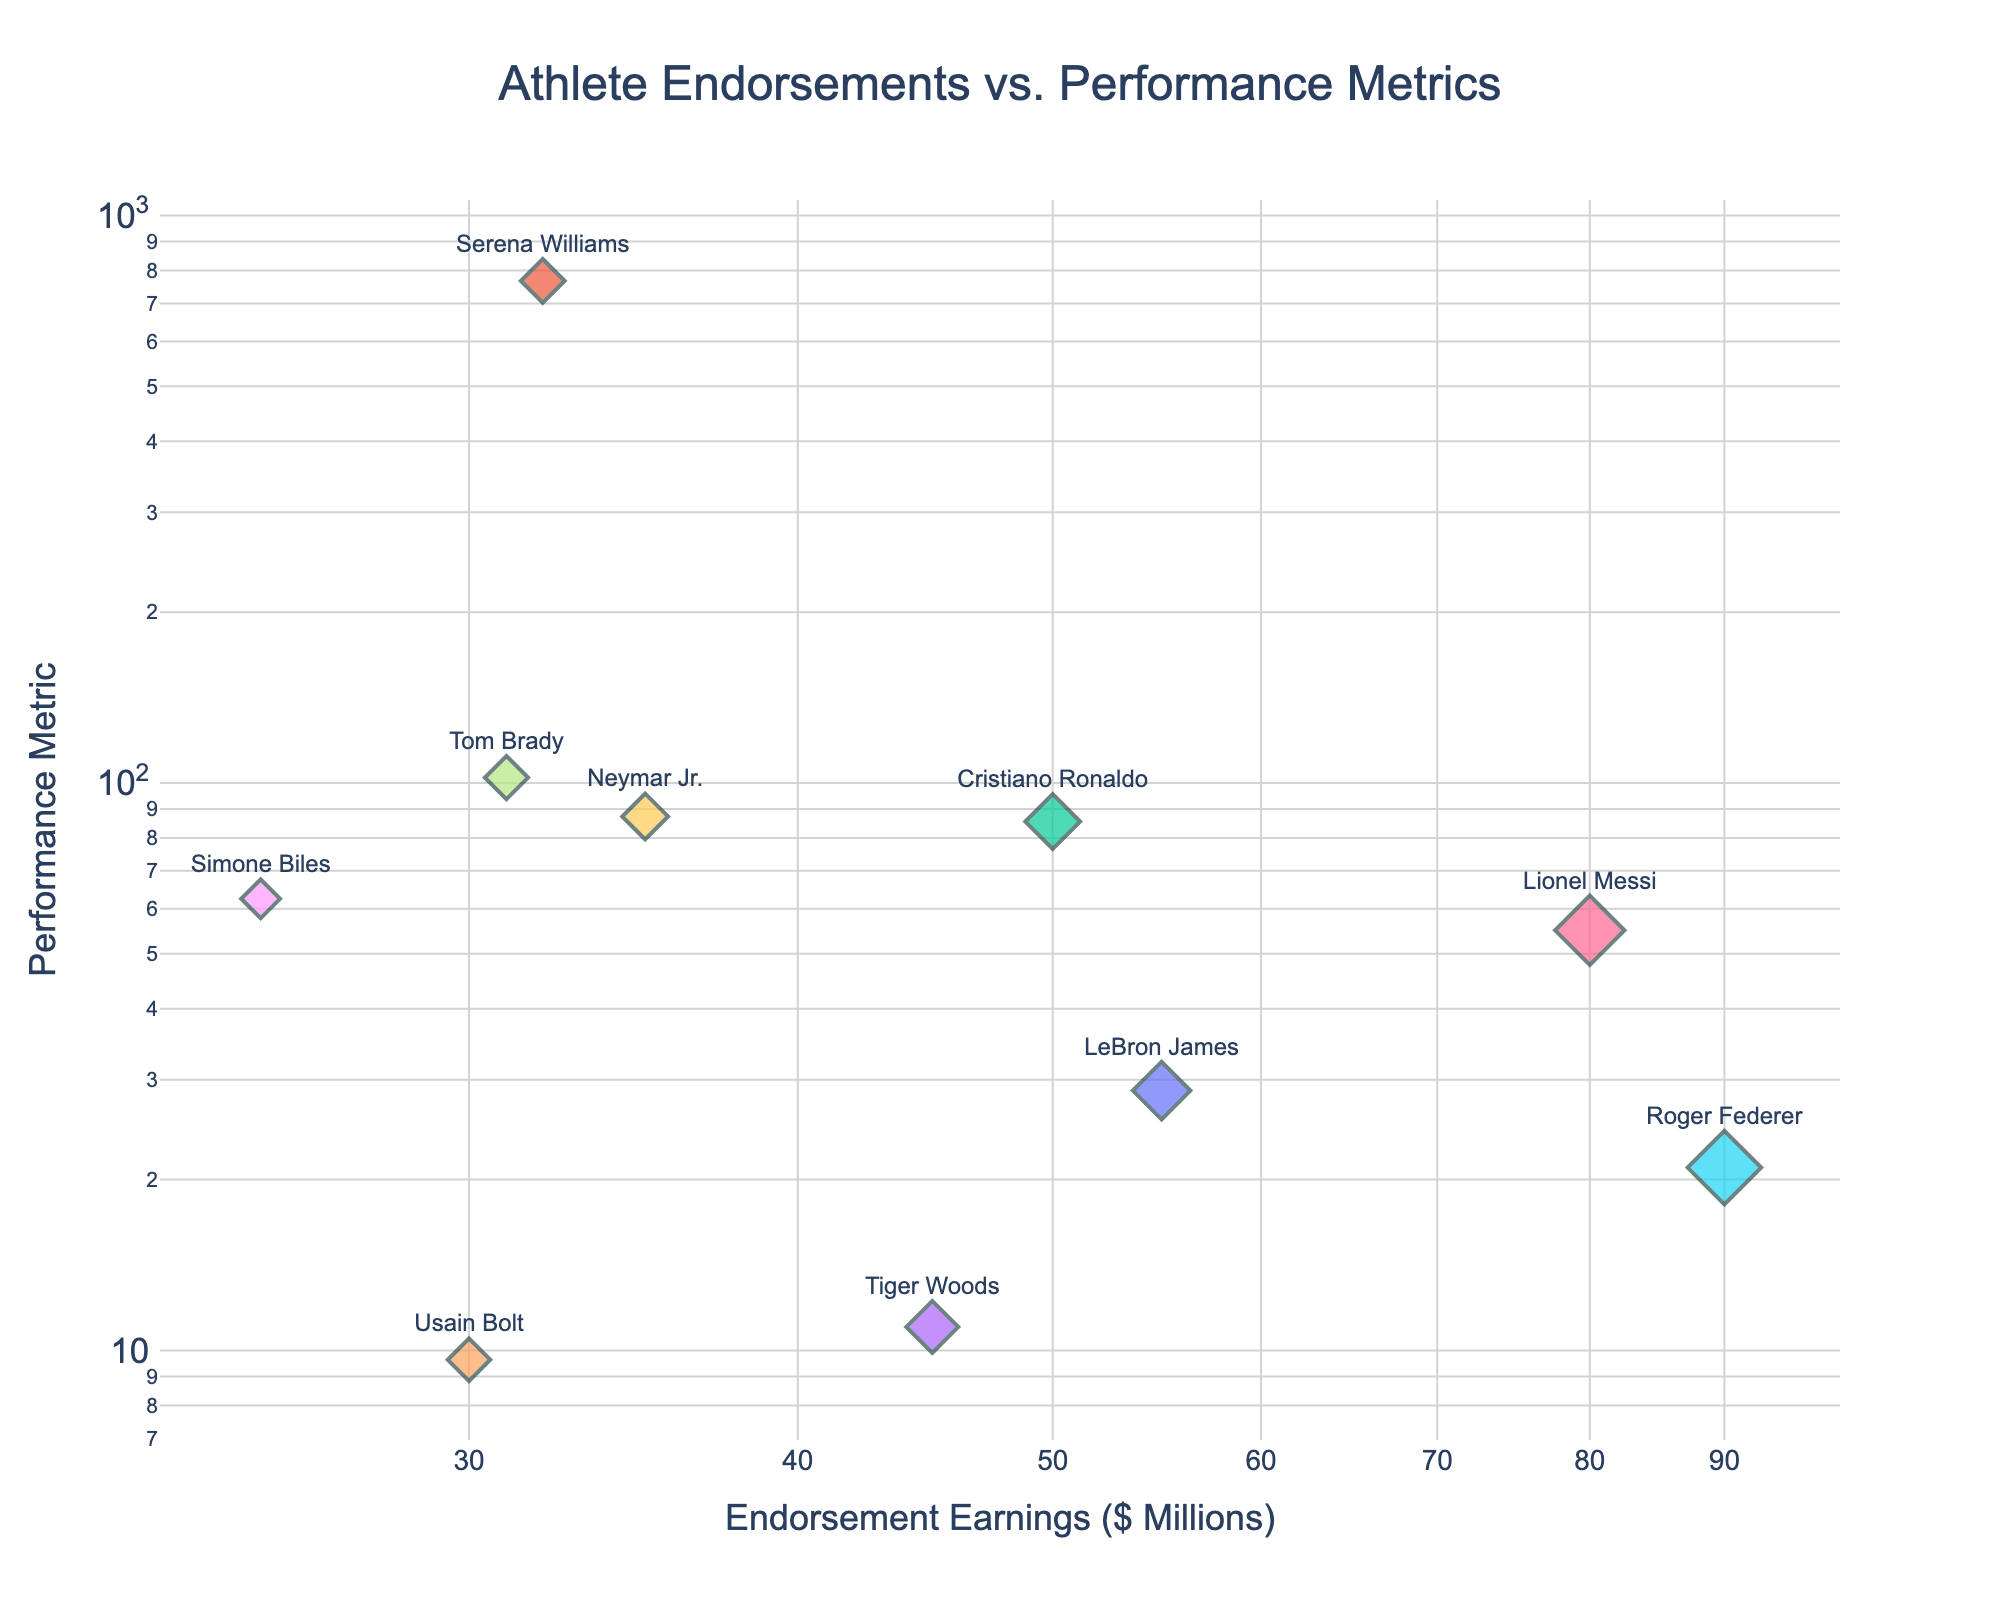What is the title of the scatter plot? The title of the scatter plot is displayed at the top center of the plot.
Answer: Athlete Endorsements vs. Performance Metrics How many athletes are represented in the plot? Count the number of distinct markers in the plot, each representing an athlete.
Answer: 10 Who has the highest endorsement earnings? Identify the athlete with the marker furthest to the right on the x-axis, which represents endorsement earnings.
Answer: Roger Federer Which athlete has the highest performance metric? Identify the athlete with the marker highest up on the y-axis, which represents the performance metric.
Answer: Tom Brady Which athlete has the lowest endorsement earnings? Identify the athlete with the marker closest to the left on the x-axis.
Answer: Simone Biles Is there a positive or negative correlation between endorsement earnings and performance metrics? Observe the general trend of the markers. If they tend to rise together, there is a positive correlation. If one rises as the other falls, there is a negative correlation.
Answer: Positive correlation Which two athletes are the closest to each other on the plot? Observe the distance between markers on the plot and identify the pair that are nearest to each other.
Answer: Usain Bolt and Tiger Woods What is the approximate ratio of endorsement earnings to performance metrics for Cristiano Ronaldo? Use the log scales of both the x-axis and y-axis to estimate Cristiano Ronaldo's endorsement earnings to performance metrics ratio.
Answer: 0.58 (50 to 85.5) How does LeBron James’ performance metric compare to his endorsement earnings? Compare the vertical and horizontal position of LeBron James' marker in the plot.
Answer: Performance metric is much higher than his endorsement earnings Who has a higher endorsement earnings, Serena Williams or Simone Biles? Compare the horizontal positions of the markers for Serena Williams and Simone Biles.
Answer: Serena Williams 